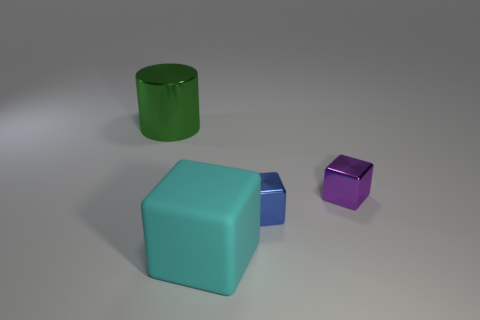The metal thing that is both on the left side of the small purple object and in front of the large shiny cylinder is what color?
Make the answer very short. Blue. How many other objects are the same material as the cyan block?
Offer a terse response. 0. Are there fewer tiny purple metal blocks than small blue metallic spheres?
Make the answer very short. No. Do the large green object and the object that is to the right of the blue metallic object have the same material?
Your answer should be compact. Yes. There is a large thing to the left of the cyan matte object; what is its shape?
Provide a succinct answer. Cylinder. Is there any other thing that is the same color as the large metal object?
Give a very brief answer. No. Are there fewer big green metal cylinders behind the purple metal thing than things?
Keep it short and to the point. Yes. What number of purple metallic cubes are the same size as the blue block?
Your answer should be compact. 1. There is a tiny shiny object in front of the small object behind the small shiny cube that is in front of the purple metal object; what is its shape?
Offer a very short reply. Cube. What color is the large object behind the cyan matte block?
Offer a very short reply. Green. 